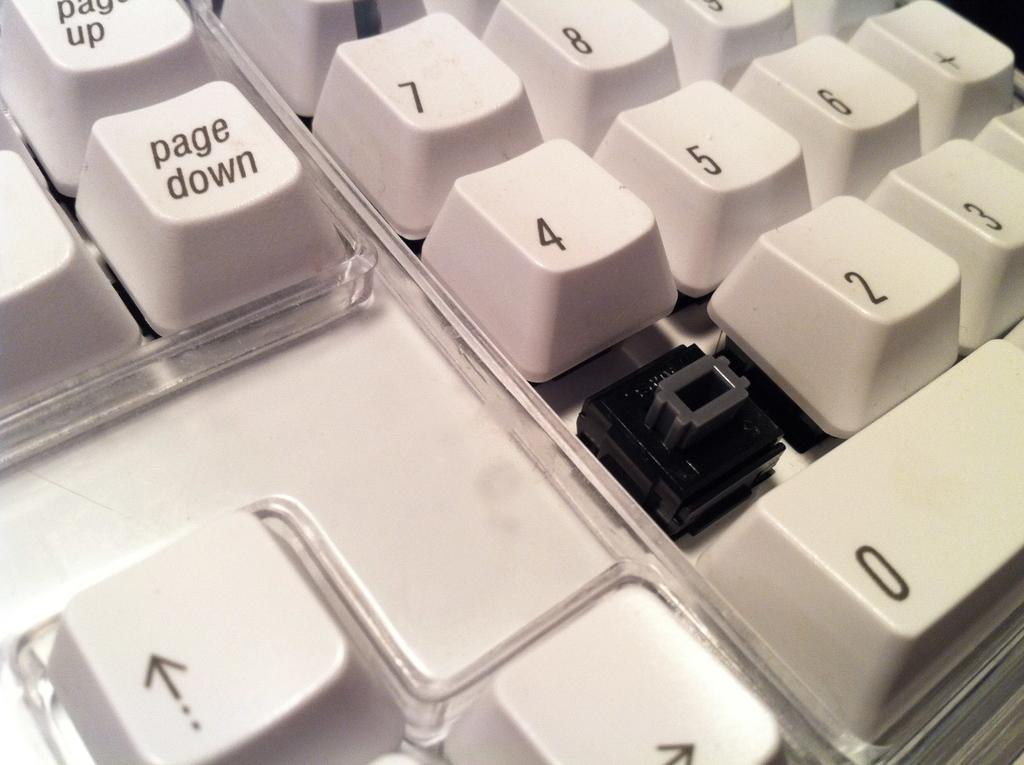<image>
Describe the image concisely. Part of a keyboard with a key missing but you can see the page down button. 